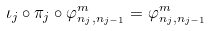Convert formula to latex. <formula><loc_0><loc_0><loc_500><loc_500>\iota _ { j } \circ \pi _ { j } \circ \varphi _ { n _ { j } , n _ { j - 1 } } ^ { m } = \varphi _ { n _ { j } , n _ { j - 1 } } ^ { m }</formula> 